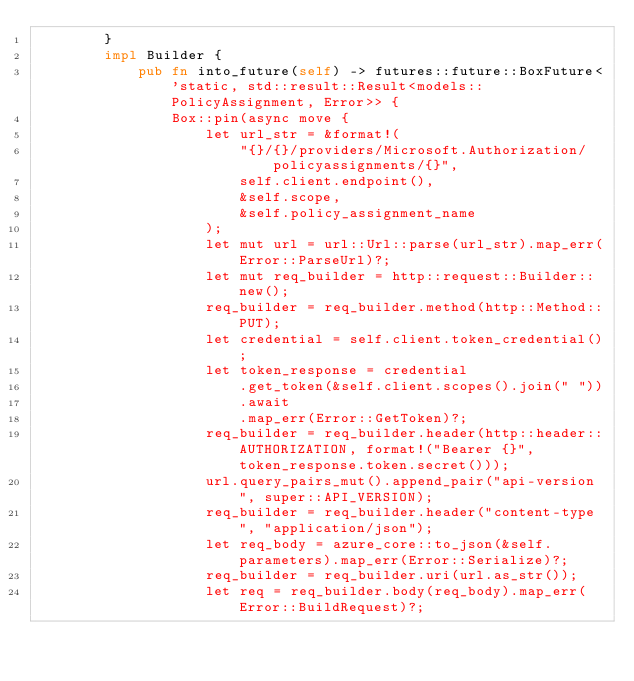<code> <loc_0><loc_0><loc_500><loc_500><_Rust_>        }
        impl Builder {
            pub fn into_future(self) -> futures::future::BoxFuture<'static, std::result::Result<models::PolicyAssignment, Error>> {
                Box::pin(async move {
                    let url_str = &format!(
                        "{}/{}/providers/Microsoft.Authorization/policyassignments/{}",
                        self.client.endpoint(),
                        &self.scope,
                        &self.policy_assignment_name
                    );
                    let mut url = url::Url::parse(url_str).map_err(Error::ParseUrl)?;
                    let mut req_builder = http::request::Builder::new();
                    req_builder = req_builder.method(http::Method::PUT);
                    let credential = self.client.token_credential();
                    let token_response = credential
                        .get_token(&self.client.scopes().join(" "))
                        .await
                        .map_err(Error::GetToken)?;
                    req_builder = req_builder.header(http::header::AUTHORIZATION, format!("Bearer {}", token_response.token.secret()));
                    url.query_pairs_mut().append_pair("api-version", super::API_VERSION);
                    req_builder = req_builder.header("content-type", "application/json");
                    let req_body = azure_core::to_json(&self.parameters).map_err(Error::Serialize)?;
                    req_builder = req_builder.uri(url.as_str());
                    let req = req_builder.body(req_body).map_err(Error::BuildRequest)?;</code> 